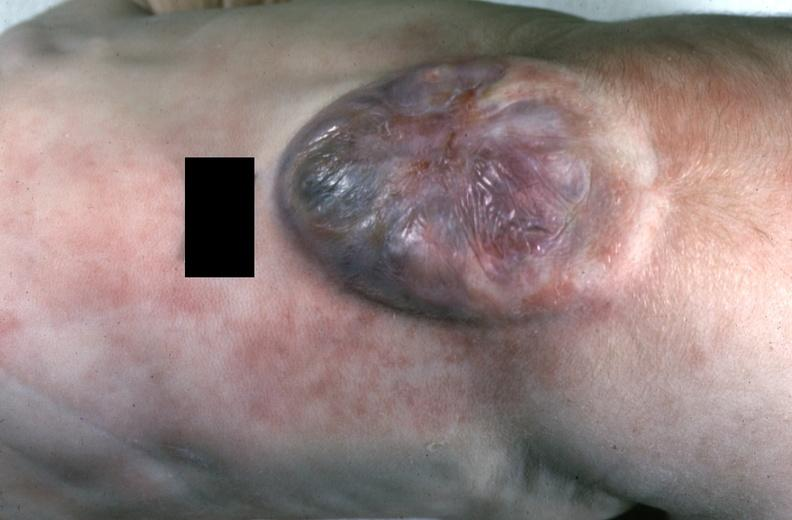does exposure show neural tube defect?
Answer the question using a single word or phrase. No 